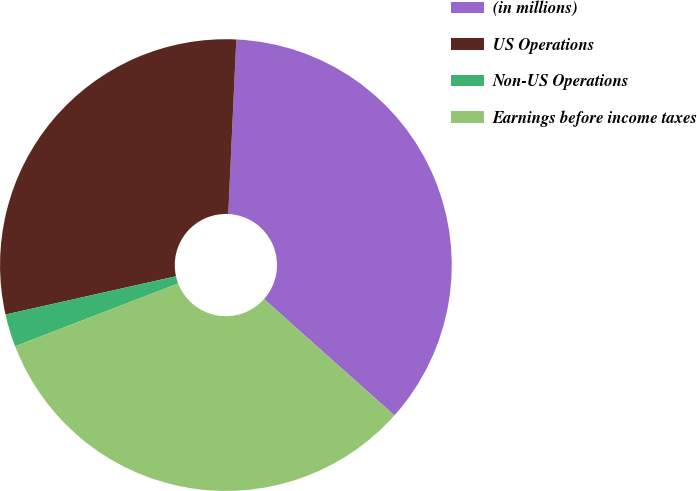<chart> <loc_0><loc_0><loc_500><loc_500><pie_chart><fcel>(in millions)<fcel>US Operations<fcel>Non-US Operations<fcel>Earnings before income taxes<nl><fcel>35.86%<fcel>29.25%<fcel>2.34%<fcel>32.55%<nl></chart> 